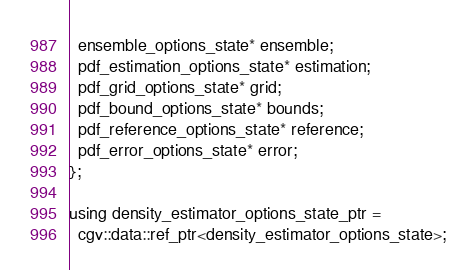<code> <loc_0><loc_0><loc_500><loc_500><_C_>  ensemble_options_state* ensemble;
  pdf_estimation_options_state* estimation;
  pdf_grid_options_state* grid;
  pdf_bound_options_state* bounds;
  pdf_reference_options_state* reference;
  pdf_error_options_state* error;
};

using density_estimator_options_state_ptr =
  cgv::data::ref_ptr<density_estimator_options_state>;
</code> 